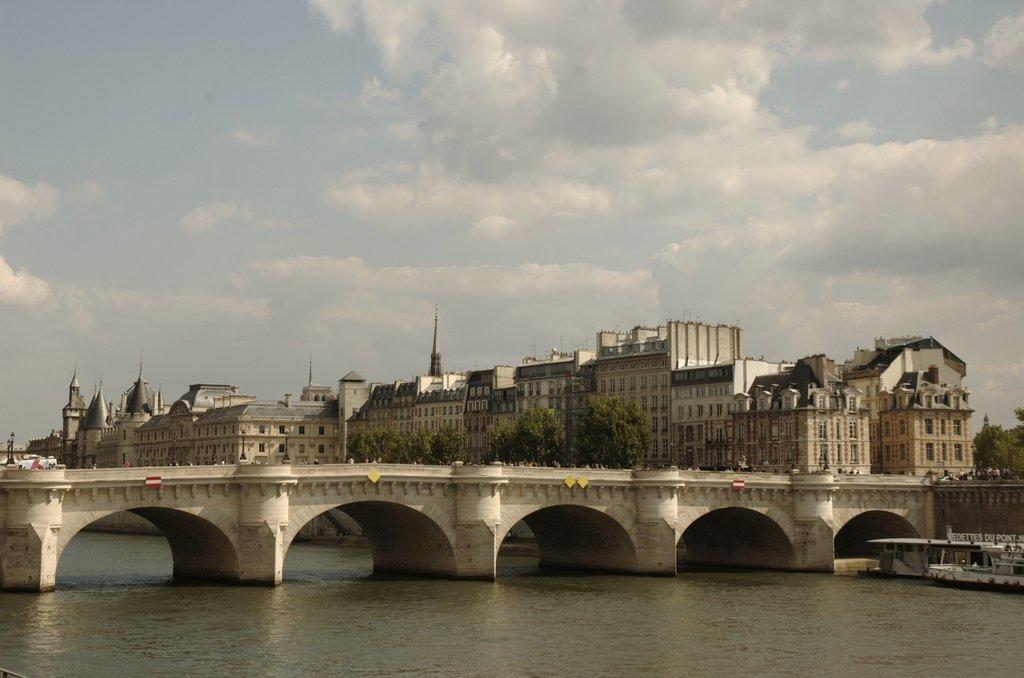What is the boat doing in the image? The boat is above the water in the image. What can be seen on the water's surface? Boards are visible in the image. What structure is present in the image? There is a bridge in the image. What else can be seen in the image? There are poles in the image. What is visible in the background of the image? There are buildings, trees, and the sky in the background of the image. What can be seen in the sky? Clouds are present in the sky. What type of organization is depicted on the dress in the image? There is no dress present in the image. Can you tell me how many guns are visible in the image? There are no guns present in the image. 